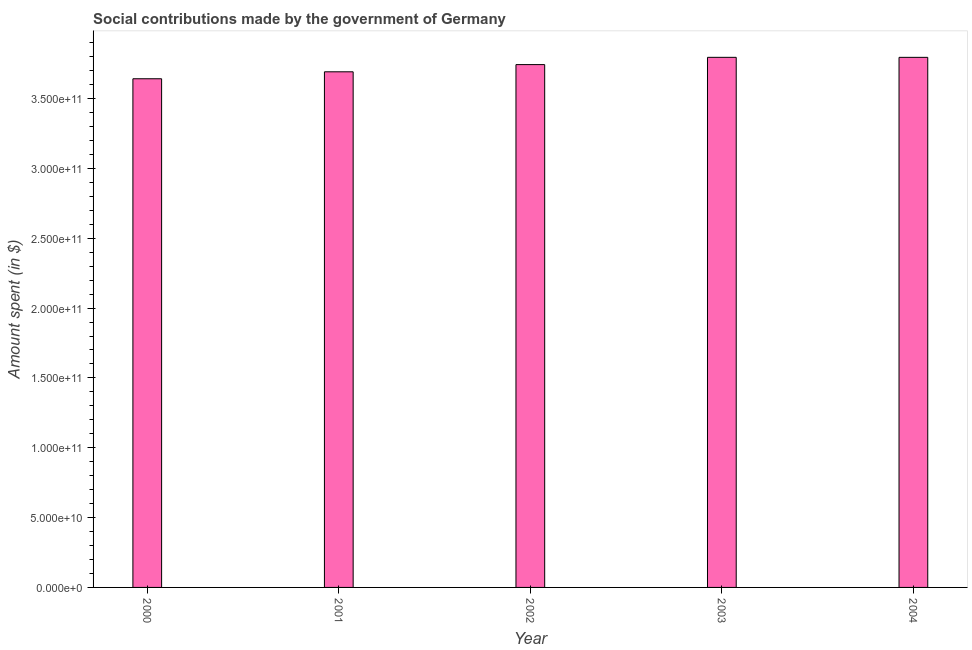What is the title of the graph?
Offer a very short reply. Social contributions made by the government of Germany. What is the label or title of the Y-axis?
Ensure brevity in your answer.  Amount spent (in $). What is the amount spent in making social contributions in 2000?
Keep it short and to the point. 3.64e+11. Across all years, what is the maximum amount spent in making social contributions?
Keep it short and to the point. 3.80e+11. Across all years, what is the minimum amount spent in making social contributions?
Your response must be concise. 3.64e+11. In which year was the amount spent in making social contributions maximum?
Your answer should be very brief. 2003. What is the sum of the amount spent in making social contributions?
Your answer should be compact. 1.87e+12. What is the difference between the amount spent in making social contributions in 2001 and 2002?
Your answer should be very brief. -5.15e+09. What is the average amount spent in making social contributions per year?
Ensure brevity in your answer.  3.73e+11. What is the median amount spent in making social contributions?
Offer a very short reply. 3.74e+11. What is the ratio of the amount spent in making social contributions in 2000 to that in 2004?
Ensure brevity in your answer.  0.96. Is the amount spent in making social contributions in 2001 less than that in 2004?
Make the answer very short. Yes. Is the difference between the amount spent in making social contributions in 2000 and 2004 greater than the difference between any two years?
Make the answer very short. No. What is the difference between the highest and the second highest amount spent in making social contributions?
Your answer should be compact. 1.00e+07. What is the difference between the highest and the lowest amount spent in making social contributions?
Your answer should be compact. 1.53e+1. In how many years, is the amount spent in making social contributions greater than the average amount spent in making social contributions taken over all years?
Your answer should be very brief. 3. How many bars are there?
Keep it short and to the point. 5. Are the values on the major ticks of Y-axis written in scientific E-notation?
Give a very brief answer. Yes. What is the Amount spent (in $) in 2000?
Offer a very short reply. 3.64e+11. What is the Amount spent (in $) of 2001?
Make the answer very short. 3.69e+11. What is the Amount spent (in $) in 2002?
Offer a terse response. 3.74e+11. What is the Amount spent (in $) of 2003?
Your answer should be very brief. 3.80e+11. What is the Amount spent (in $) of 2004?
Provide a short and direct response. 3.80e+11. What is the difference between the Amount spent (in $) in 2000 and 2001?
Provide a short and direct response. -4.98e+09. What is the difference between the Amount spent (in $) in 2000 and 2002?
Keep it short and to the point. -1.01e+1. What is the difference between the Amount spent (in $) in 2000 and 2003?
Your answer should be very brief. -1.53e+1. What is the difference between the Amount spent (in $) in 2000 and 2004?
Your response must be concise. -1.53e+1. What is the difference between the Amount spent (in $) in 2001 and 2002?
Your answer should be very brief. -5.15e+09. What is the difference between the Amount spent (in $) in 2001 and 2003?
Your response must be concise. -1.04e+1. What is the difference between the Amount spent (in $) in 2001 and 2004?
Your response must be concise. -1.04e+1. What is the difference between the Amount spent (in $) in 2002 and 2003?
Ensure brevity in your answer.  -5.21e+09. What is the difference between the Amount spent (in $) in 2002 and 2004?
Offer a very short reply. -5.20e+09. What is the difference between the Amount spent (in $) in 2003 and 2004?
Give a very brief answer. 1.00e+07. What is the ratio of the Amount spent (in $) in 2000 to that in 2001?
Ensure brevity in your answer.  0.99. What is the ratio of the Amount spent (in $) in 2003 to that in 2004?
Make the answer very short. 1. 